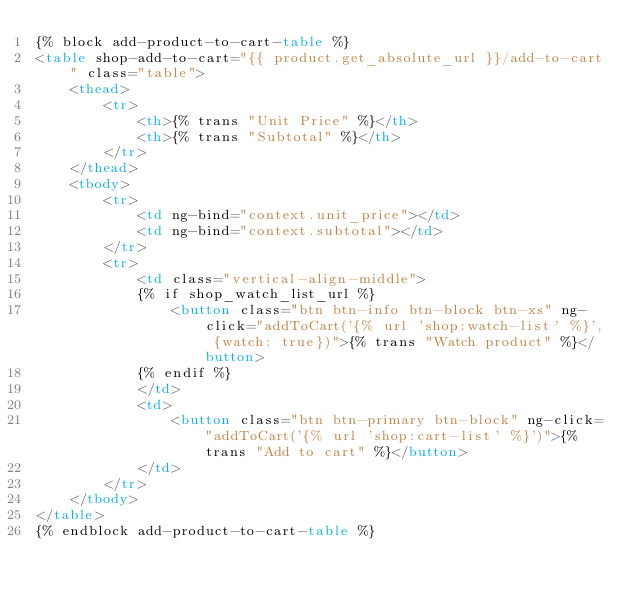<code> <loc_0><loc_0><loc_500><loc_500><_HTML_>{% block add-product-to-cart-table %}
<table shop-add-to-cart="{{ product.get_absolute_url }}/add-to-cart" class="table">
	<thead>
		<tr>
			<th>{% trans "Unit Price" %}</th>
			<th>{% trans "Subtotal" %}</th>
		</tr>
	</thead>
	<tbody>
		<tr>
			<td ng-bind="context.unit_price"></td>
			<td ng-bind="context.subtotal"></td>
		</tr>
		<tr>
			<td class="vertical-align-middle">
			{% if shop_watch_list_url %}
				<button class="btn btn-info btn-block btn-xs" ng-click="addToCart('{% url 'shop:watch-list' %}', {watch: true})">{% trans "Watch product" %}</button>
			{% endif %}
			</td>
			<td>
				<button class="btn btn-primary btn-block" ng-click="addToCart('{% url 'shop:cart-list' %}')">{% trans "Add to cart" %}</button>
			</td>
		</tr>
	</tbody>
</table>
{% endblock add-product-to-cart-table %}
</code> 